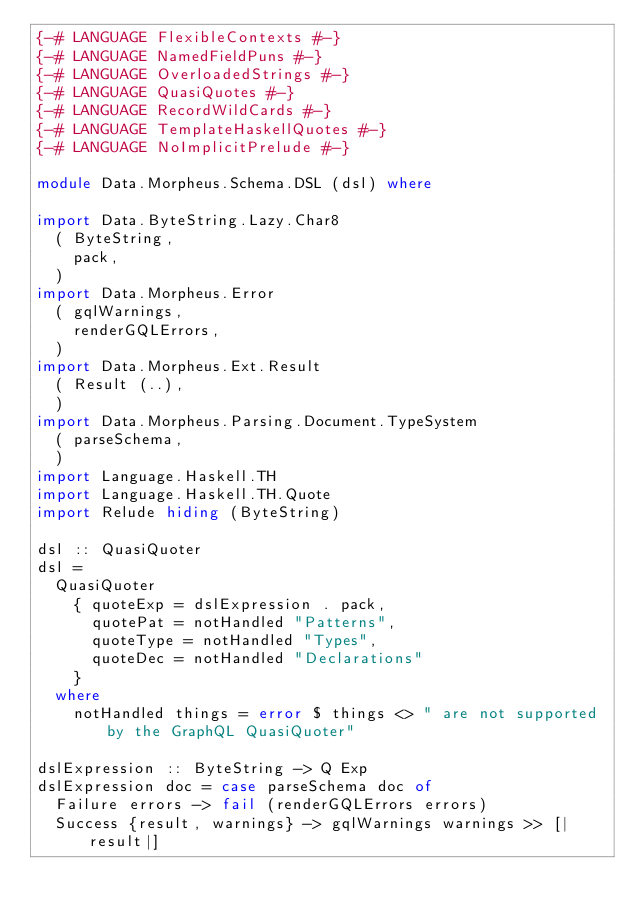<code> <loc_0><loc_0><loc_500><loc_500><_Haskell_>{-# LANGUAGE FlexibleContexts #-}
{-# LANGUAGE NamedFieldPuns #-}
{-# LANGUAGE OverloadedStrings #-}
{-# LANGUAGE QuasiQuotes #-}
{-# LANGUAGE RecordWildCards #-}
{-# LANGUAGE TemplateHaskellQuotes #-}
{-# LANGUAGE NoImplicitPrelude #-}

module Data.Morpheus.Schema.DSL (dsl) where

import Data.ByteString.Lazy.Char8
  ( ByteString,
    pack,
  )
import Data.Morpheus.Error
  ( gqlWarnings,
    renderGQLErrors,
  )
import Data.Morpheus.Ext.Result
  ( Result (..),
  )
import Data.Morpheus.Parsing.Document.TypeSystem
  ( parseSchema,
  )
import Language.Haskell.TH
import Language.Haskell.TH.Quote
import Relude hiding (ByteString)

dsl :: QuasiQuoter
dsl =
  QuasiQuoter
    { quoteExp = dslExpression . pack,
      quotePat = notHandled "Patterns",
      quoteType = notHandled "Types",
      quoteDec = notHandled "Declarations"
    }
  where
    notHandled things = error $ things <> " are not supported by the GraphQL QuasiQuoter"

dslExpression :: ByteString -> Q Exp
dslExpression doc = case parseSchema doc of
  Failure errors -> fail (renderGQLErrors errors)
  Success {result, warnings} -> gqlWarnings warnings >> [|result|]
</code> 